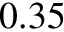<formula> <loc_0><loc_0><loc_500><loc_500>0 . 3 5</formula> 